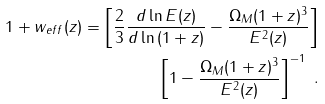<formula> <loc_0><loc_0><loc_500><loc_500>1 + w _ { e f f } ( z ) = \left [ \frac { 2 } { 3 } \frac { d \ln { E ( z ) } } { d \ln { ( 1 + z ) } } - \frac { \Omega _ { M } ( 1 + z ) ^ { 3 } } { E ^ { 2 } ( z ) } \right ] \\ \left [ 1 - \frac { \Omega _ { M } ( 1 + z ) ^ { 3 } } { E ^ { 2 } ( z ) } \right ] ^ { - 1 } \ .</formula> 